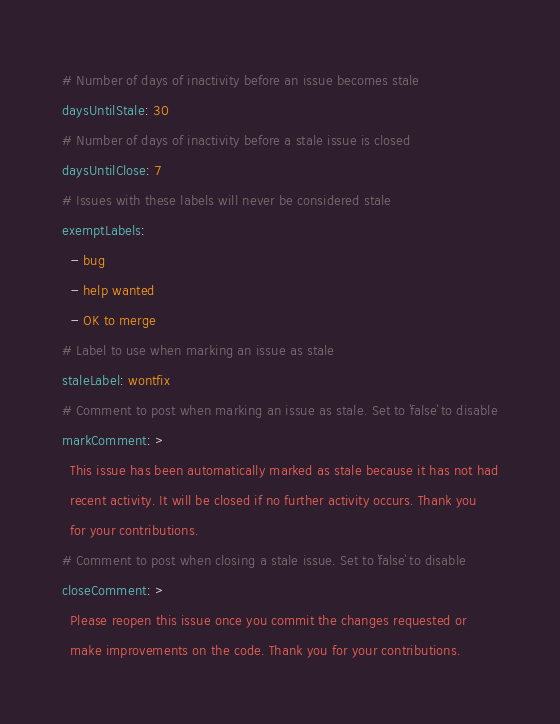Convert code to text. <code><loc_0><loc_0><loc_500><loc_500><_YAML_># Number of days of inactivity before an issue becomes stale
daysUntilStale: 30
# Number of days of inactivity before a stale issue is closed
daysUntilClose: 7
# Issues with these labels will never be considered stale
exemptLabels:
  - bug
  - help wanted
  - OK to merge
# Label to use when marking an issue as stale
staleLabel: wontfix
# Comment to post when marking an issue as stale. Set to `false` to disable
markComment: >
  This issue has been automatically marked as stale because it has not had
  recent activity. It will be closed if no further activity occurs. Thank you
  for your contributions.
# Comment to post when closing a stale issue. Set to `false` to disable
closeComment: >
  Please reopen this issue once you commit the changes requested or 
  make improvements on the code. Thank you for your contributions.</code> 